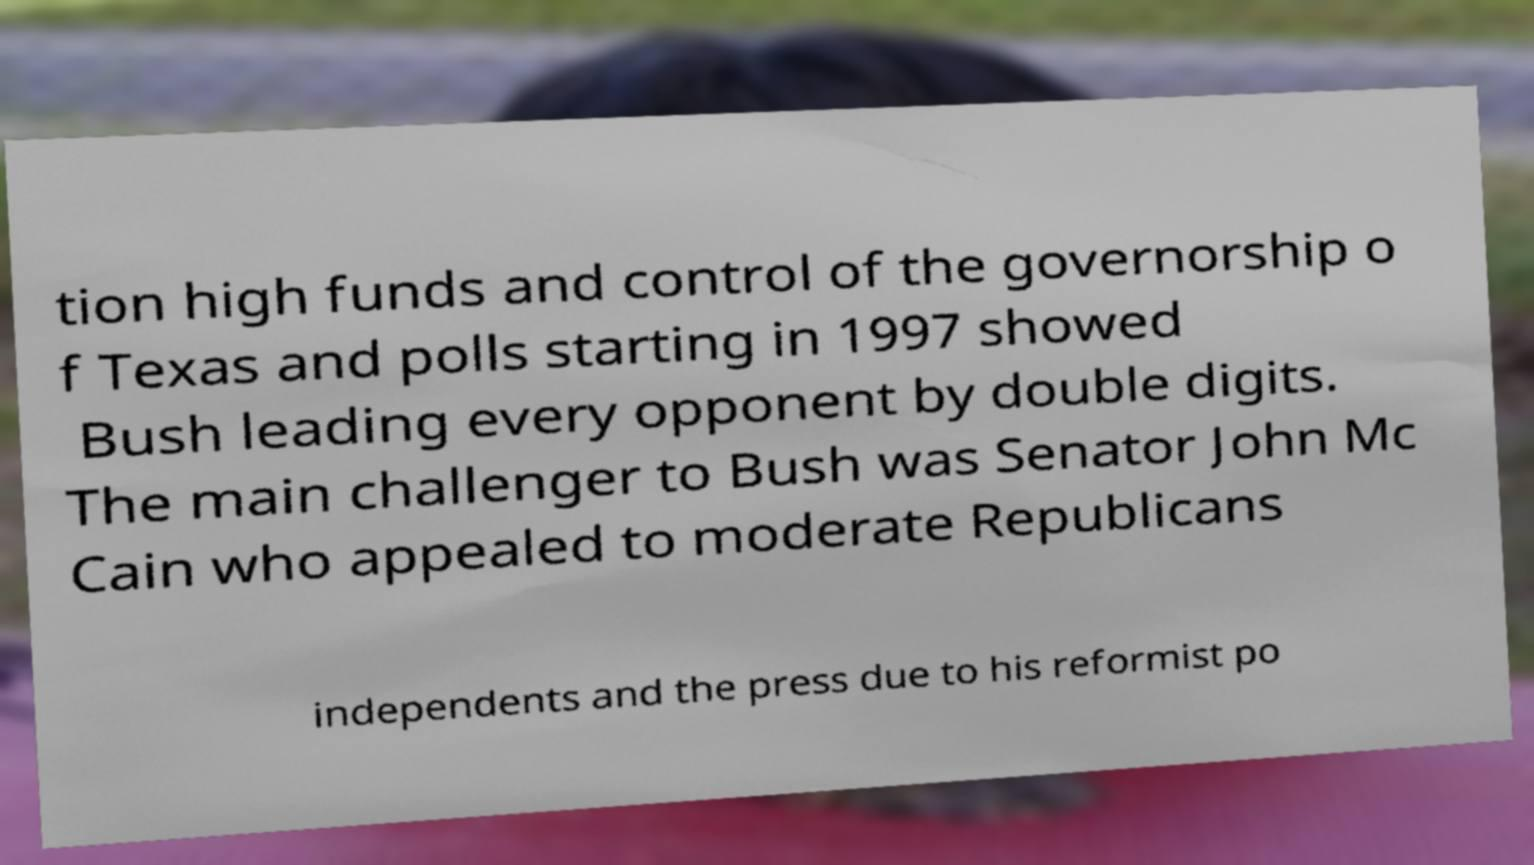Could you assist in decoding the text presented in this image and type it out clearly? tion high funds and control of the governorship o f Texas and polls starting in 1997 showed Bush leading every opponent by double digits. The main challenger to Bush was Senator John Mc Cain who appealed to moderate Republicans independents and the press due to his reformist po 